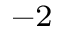<formula> <loc_0><loc_0><loc_500><loc_500>^ { - 2 }</formula> 